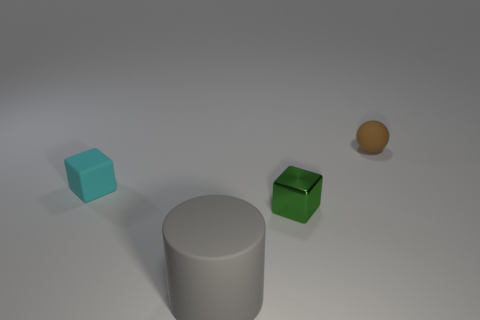How many blocks are either big gray rubber objects or big cyan objects?
Your answer should be very brief. 0. Are any brown metallic spheres visible?
Ensure brevity in your answer.  No. Is there any other thing that has the same shape as the brown object?
Offer a terse response. No. What number of objects are either cubes that are on the right side of the big matte object or yellow rubber objects?
Keep it short and to the point. 1. How many cylinders are right of the cube in front of the tiny rubber object in front of the small brown matte thing?
Your answer should be compact. 0. Is there anything else that has the same size as the gray object?
Make the answer very short. No. There is a tiny matte thing in front of the thing that is behind the small rubber thing in front of the tiny brown matte ball; what shape is it?
Keep it short and to the point. Cube. What number of other things are the same color as the rubber cube?
Offer a very short reply. 0. The tiny thing that is in front of the tiny matte object that is in front of the tiny brown thing is what shape?
Your answer should be compact. Cube. What number of tiny metal objects are in front of the tiny cyan block?
Offer a terse response. 1. 